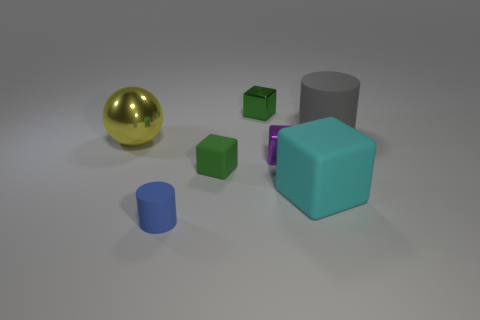There is a green block that is in front of the tiny green cube behind the big rubber object right of the large cyan matte block; what is its material?
Provide a succinct answer. Rubber. Are there the same number of yellow metallic things that are in front of the blue object and blue matte spheres?
Your answer should be compact. Yes. Is there any other thing that is the same size as the yellow thing?
Your response must be concise. Yes. How many objects are small gray rubber cubes or purple things?
Your answer should be very brief. 1. There is a tiny green object that is the same material as the gray cylinder; what is its shape?
Make the answer very short. Cube. There is a object behind the matte cylinder on the right side of the big cyan block; what size is it?
Offer a terse response. Small. How many small objects are either shiny spheres or red blocks?
Provide a succinct answer. 0. How many other objects are there of the same color as the small matte block?
Make the answer very short. 1. There is a cylinder that is behind the tiny blue object; is its size the same as the matte cylinder in front of the purple object?
Your answer should be very brief. No. Do the big cyan object and the cylinder that is behind the blue matte cylinder have the same material?
Your answer should be compact. Yes. 